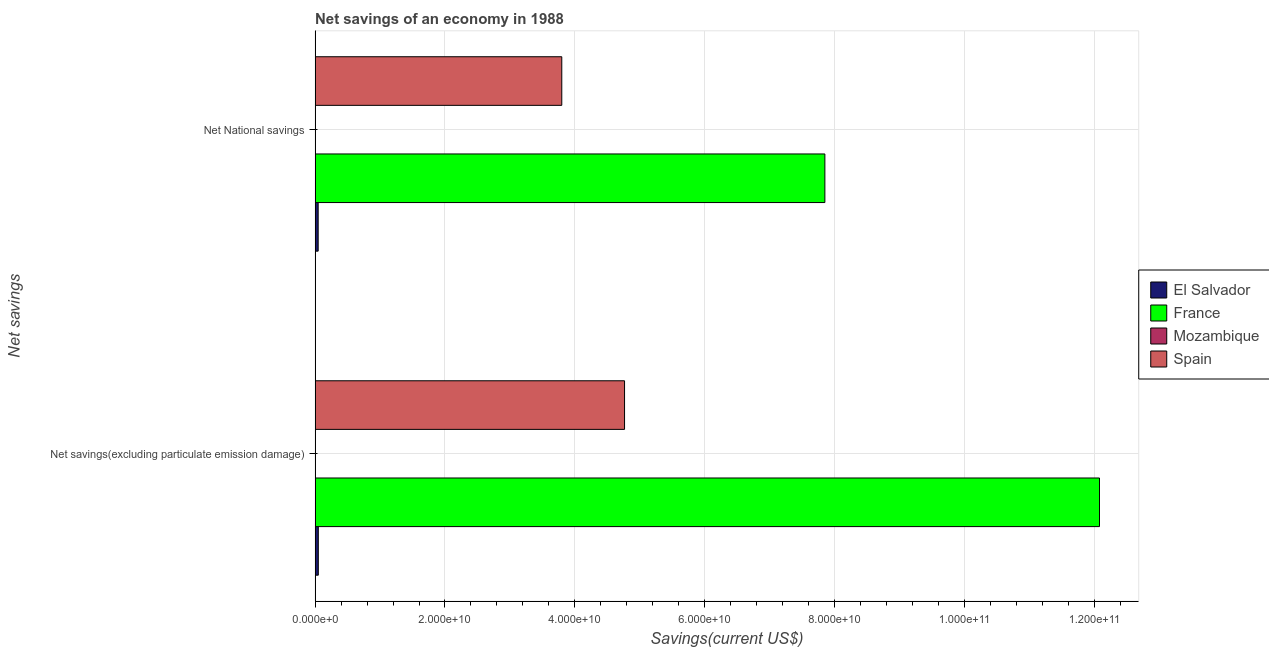How many different coloured bars are there?
Keep it short and to the point. 3. How many groups of bars are there?
Your answer should be compact. 2. Are the number of bars on each tick of the Y-axis equal?
Your answer should be compact. Yes. How many bars are there on the 1st tick from the bottom?
Ensure brevity in your answer.  3. What is the label of the 2nd group of bars from the top?
Provide a succinct answer. Net savings(excluding particulate emission damage). What is the net savings(excluding particulate emission damage) in Mozambique?
Give a very brief answer. 0. Across all countries, what is the maximum net national savings?
Provide a short and direct response. 7.85e+1. What is the total net savings(excluding particulate emission damage) in the graph?
Give a very brief answer. 1.69e+11. What is the difference between the net savings(excluding particulate emission damage) in Spain and that in El Salvador?
Offer a terse response. 4.72e+1. What is the difference between the net national savings in El Salvador and the net savings(excluding particulate emission damage) in Mozambique?
Your answer should be very brief. 4.72e+08. What is the average net savings(excluding particulate emission damage) per country?
Give a very brief answer. 4.22e+1. What is the difference between the net national savings and net savings(excluding particulate emission damage) in El Salvador?
Offer a terse response. -2.24e+07. In how many countries, is the net savings(excluding particulate emission damage) greater than 92000000000 US$?
Ensure brevity in your answer.  1. What is the ratio of the net savings(excluding particulate emission damage) in El Salvador to that in Spain?
Make the answer very short. 0.01. In how many countries, is the net savings(excluding particulate emission damage) greater than the average net savings(excluding particulate emission damage) taken over all countries?
Make the answer very short. 2. Does the graph contain any zero values?
Provide a short and direct response. Yes. Does the graph contain grids?
Offer a terse response. Yes. How many legend labels are there?
Give a very brief answer. 4. What is the title of the graph?
Make the answer very short. Net savings of an economy in 1988. What is the label or title of the X-axis?
Provide a succinct answer. Savings(current US$). What is the label or title of the Y-axis?
Your answer should be compact. Net savings. What is the Savings(current US$) in El Salvador in Net savings(excluding particulate emission damage)?
Offer a terse response. 4.94e+08. What is the Savings(current US$) in France in Net savings(excluding particulate emission damage)?
Your response must be concise. 1.21e+11. What is the Savings(current US$) of Mozambique in Net savings(excluding particulate emission damage)?
Keep it short and to the point. 0. What is the Savings(current US$) of Spain in Net savings(excluding particulate emission damage)?
Give a very brief answer. 4.76e+1. What is the Savings(current US$) in El Salvador in Net National savings?
Keep it short and to the point. 4.72e+08. What is the Savings(current US$) in France in Net National savings?
Keep it short and to the point. 7.85e+1. What is the Savings(current US$) of Mozambique in Net National savings?
Your answer should be very brief. 0. What is the Savings(current US$) of Spain in Net National savings?
Keep it short and to the point. 3.80e+1. Across all Net savings, what is the maximum Savings(current US$) of El Salvador?
Provide a short and direct response. 4.94e+08. Across all Net savings, what is the maximum Savings(current US$) in France?
Offer a terse response. 1.21e+11. Across all Net savings, what is the maximum Savings(current US$) in Spain?
Offer a terse response. 4.76e+1. Across all Net savings, what is the minimum Savings(current US$) in El Salvador?
Your answer should be compact. 4.72e+08. Across all Net savings, what is the minimum Savings(current US$) of France?
Offer a very short reply. 7.85e+1. Across all Net savings, what is the minimum Savings(current US$) in Spain?
Your answer should be very brief. 3.80e+1. What is the total Savings(current US$) of El Salvador in the graph?
Keep it short and to the point. 9.66e+08. What is the total Savings(current US$) of France in the graph?
Provide a short and direct response. 1.99e+11. What is the total Savings(current US$) of Mozambique in the graph?
Make the answer very short. 0. What is the total Savings(current US$) in Spain in the graph?
Provide a short and direct response. 8.56e+1. What is the difference between the Savings(current US$) in El Salvador in Net savings(excluding particulate emission damage) and that in Net National savings?
Your answer should be very brief. 2.24e+07. What is the difference between the Savings(current US$) in France in Net savings(excluding particulate emission damage) and that in Net National savings?
Offer a very short reply. 4.23e+1. What is the difference between the Savings(current US$) of Spain in Net savings(excluding particulate emission damage) and that in Net National savings?
Keep it short and to the point. 9.67e+09. What is the difference between the Savings(current US$) of El Salvador in Net savings(excluding particulate emission damage) and the Savings(current US$) of France in Net National savings?
Your response must be concise. -7.80e+1. What is the difference between the Savings(current US$) in El Salvador in Net savings(excluding particulate emission damage) and the Savings(current US$) in Spain in Net National savings?
Give a very brief answer. -3.75e+1. What is the difference between the Savings(current US$) of France in Net savings(excluding particulate emission damage) and the Savings(current US$) of Spain in Net National savings?
Keep it short and to the point. 8.28e+1. What is the average Savings(current US$) of El Salvador per Net savings?
Offer a very short reply. 4.83e+08. What is the average Savings(current US$) of France per Net savings?
Your answer should be very brief. 9.96e+1. What is the average Savings(current US$) of Spain per Net savings?
Make the answer very short. 4.28e+1. What is the difference between the Savings(current US$) of El Salvador and Savings(current US$) of France in Net savings(excluding particulate emission damage)?
Give a very brief answer. -1.20e+11. What is the difference between the Savings(current US$) in El Salvador and Savings(current US$) in Spain in Net savings(excluding particulate emission damage)?
Keep it short and to the point. -4.72e+1. What is the difference between the Savings(current US$) of France and Savings(current US$) of Spain in Net savings(excluding particulate emission damage)?
Offer a terse response. 7.31e+1. What is the difference between the Savings(current US$) of El Salvador and Savings(current US$) of France in Net National savings?
Provide a short and direct response. -7.80e+1. What is the difference between the Savings(current US$) in El Salvador and Savings(current US$) in Spain in Net National savings?
Your answer should be very brief. -3.75e+1. What is the difference between the Savings(current US$) of France and Savings(current US$) of Spain in Net National savings?
Keep it short and to the point. 4.05e+1. What is the ratio of the Savings(current US$) of El Salvador in Net savings(excluding particulate emission damage) to that in Net National savings?
Your answer should be very brief. 1.05. What is the ratio of the Savings(current US$) in France in Net savings(excluding particulate emission damage) to that in Net National savings?
Your answer should be very brief. 1.54. What is the ratio of the Savings(current US$) in Spain in Net savings(excluding particulate emission damage) to that in Net National savings?
Provide a succinct answer. 1.25. What is the difference between the highest and the second highest Savings(current US$) of El Salvador?
Make the answer very short. 2.24e+07. What is the difference between the highest and the second highest Savings(current US$) in France?
Give a very brief answer. 4.23e+1. What is the difference between the highest and the second highest Savings(current US$) of Spain?
Provide a short and direct response. 9.67e+09. What is the difference between the highest and the lowest Savings(current US$) of El Salvador?
Make the answer very short. 2.24e+07. What is the difference between the highest and the lowest Savings(current US$) of France?
Make the answer very short. 4.23e+1. What is the difference between the highest and the lowest Savings(current US$) of Spain?
Your response must be concise. 9.67e+09. 